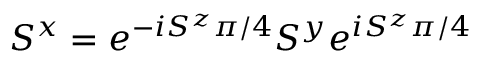<formula> <loc_0><loc_0><loc_500><loc_500>S ^ { x } = e ^ { - i S ^ { z } \pi / 4 } S ^ { y } e ^ { i S ^ { z } \pi / 4 }</formula> 